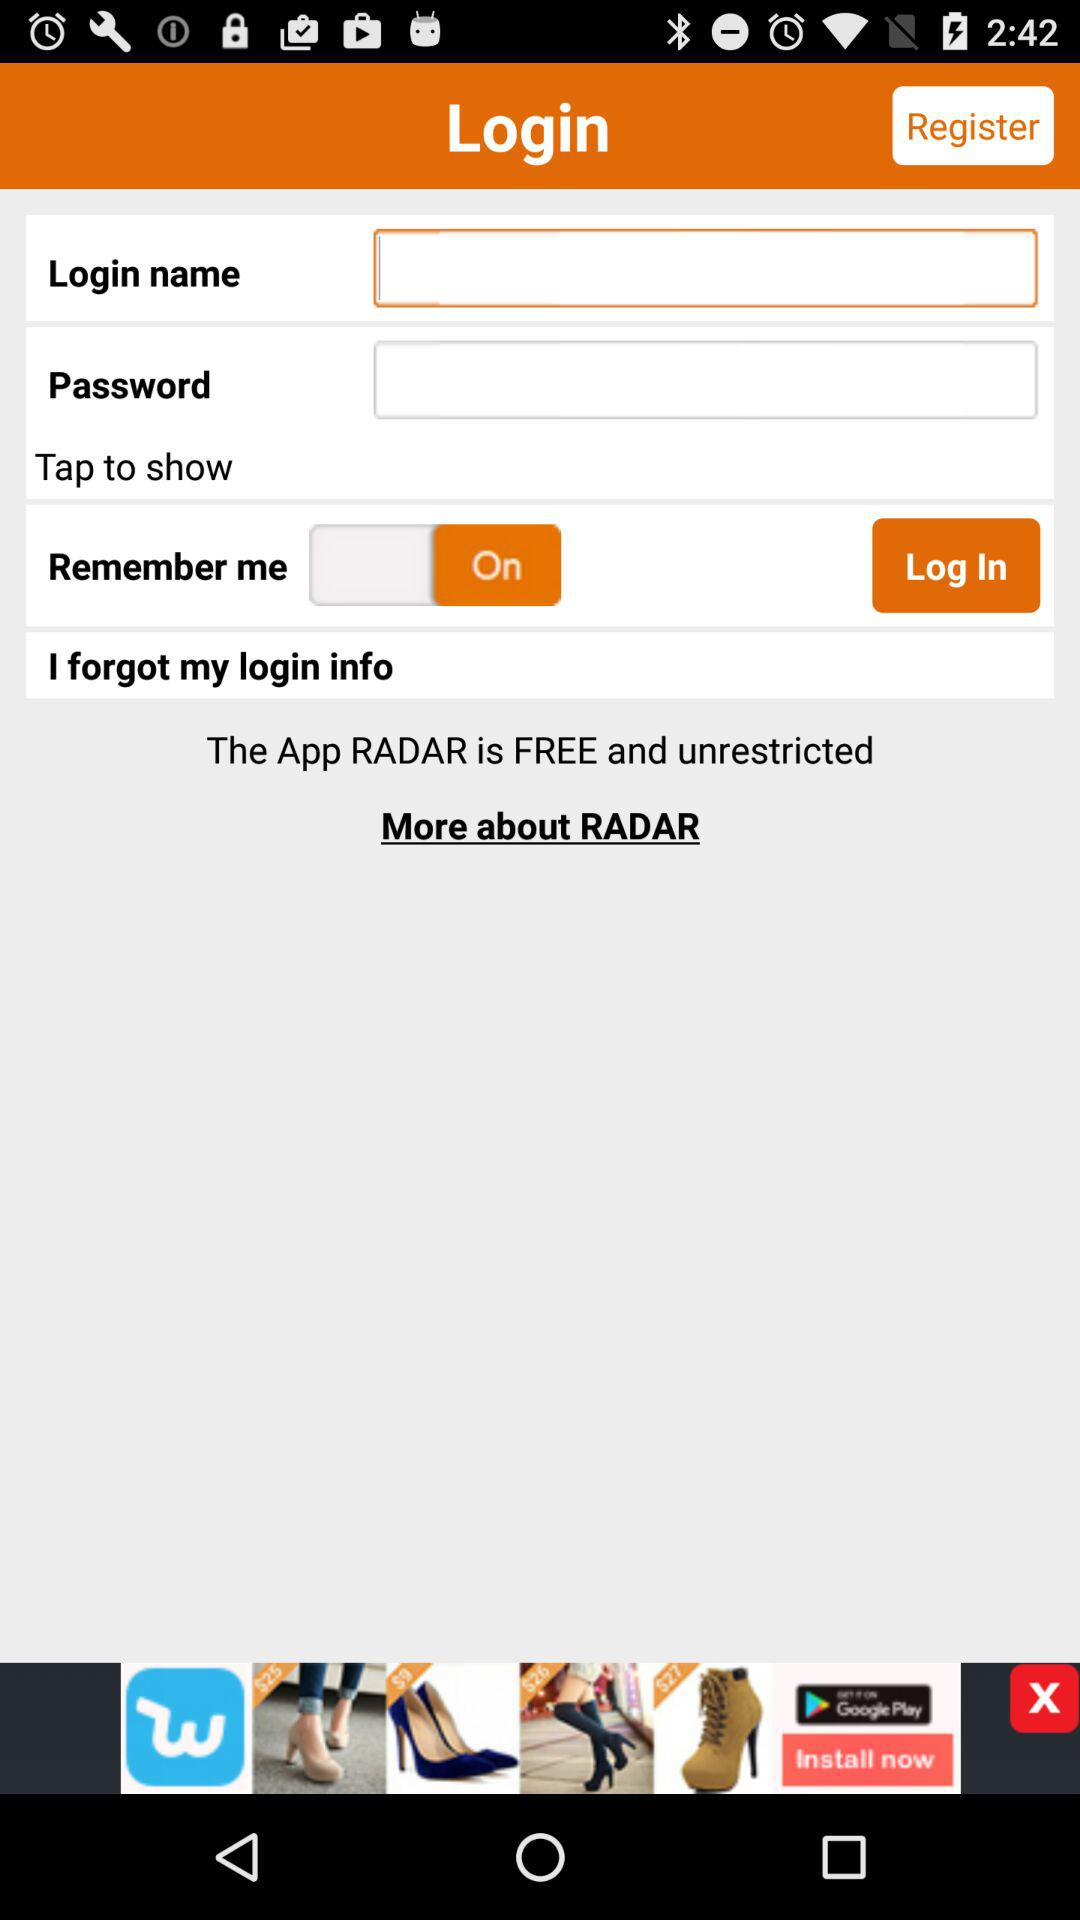What is the status of "remember me"? The status is "On". 